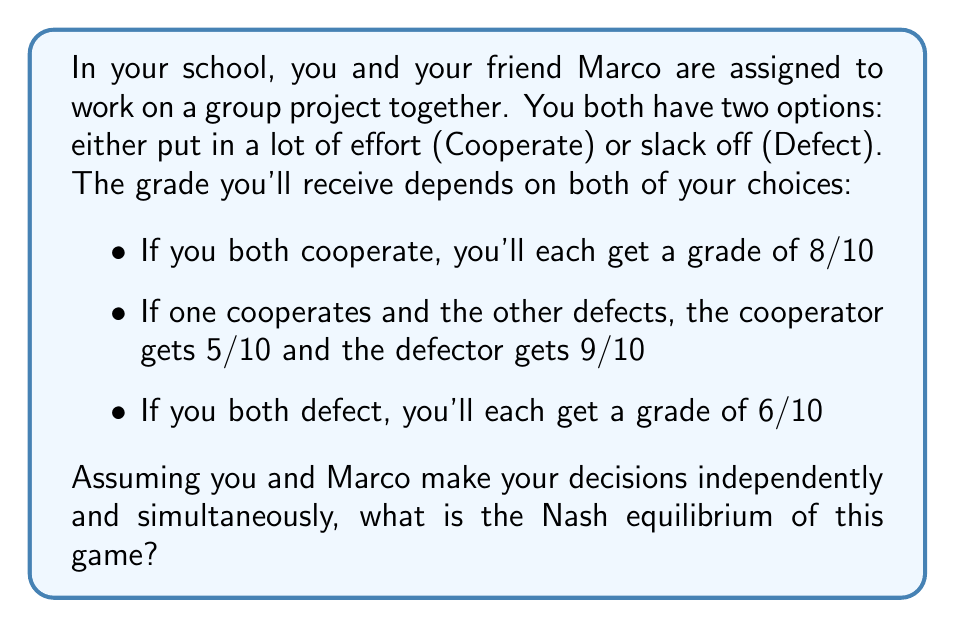Solve this math problem. To solve this problem, we need to understand the concept of Nash equilibrium and analyze the payoff matrix for this scenario.

1. Let's first create a payoff matrix:

   ```
   [asy]
   unitsize(1cm);
   
   draw((0,0)--(4,0)--(4,4)--(0,4)--cycle);
   draw((0,2)--(4,2));
   draw((2,0)--(2,4));
   
   label("You / Marco", (1,3.5), fontsize(8));
   label("Cooperate", (1,2.5), fontsize(8));
   label("Defect", (1,1.5), fontsize(8));
   label("Cooperate", (3,3.5), fontsize(8));
   label("Defect", (3,3.5), fontsize(8));
   
   label("8, 8", (3,2.5), fontsize(8));
   label("5, 9", (3,1.5), fontsize(8));
   label("9, 5", (1,2.5), fontsize(8));
   label("6, 6", (1,1.5), fontsize(8));
   [/asy]
   ```

2. A Nash equilibrium occurs when neither player can unilaterally improve their outcome by changing their strategy.

3. Let's analyze each player's best response to the other's strategy:

   For You:
   - If Marco cooperates, you're better off defecting (9 > 8)
   - If Marco defects, you're better off defecting (6 > 5)

   For Marco:
   - If you cooperate, Marco is better off defecting (9 > 8)
   - If you defect, Marco is better off defecting (6 > 5)

4. We can see that regardless of what the other player does, each player's best strategy is to defect.

5. Therefore, the Nash equilibrium is (Defect, Defect), where both players choose to slack off.

This situation demonstrates the essence of the Prisoner's Dilemma. Although both players would be better off if they both cooperated (8, 8), the Nash equilibrium results in a worse outcome for both (6, 6).
Answer: The Nash equilibrium is (Defect, Defect), where both you and Marco choose to slack off on the project. 